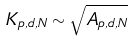<formula> <loc_0><loc_0><loc_500><loc_500>K _ { p , d , N } \sim \sqrt { A _ { p , d , N } } \,</formula> 